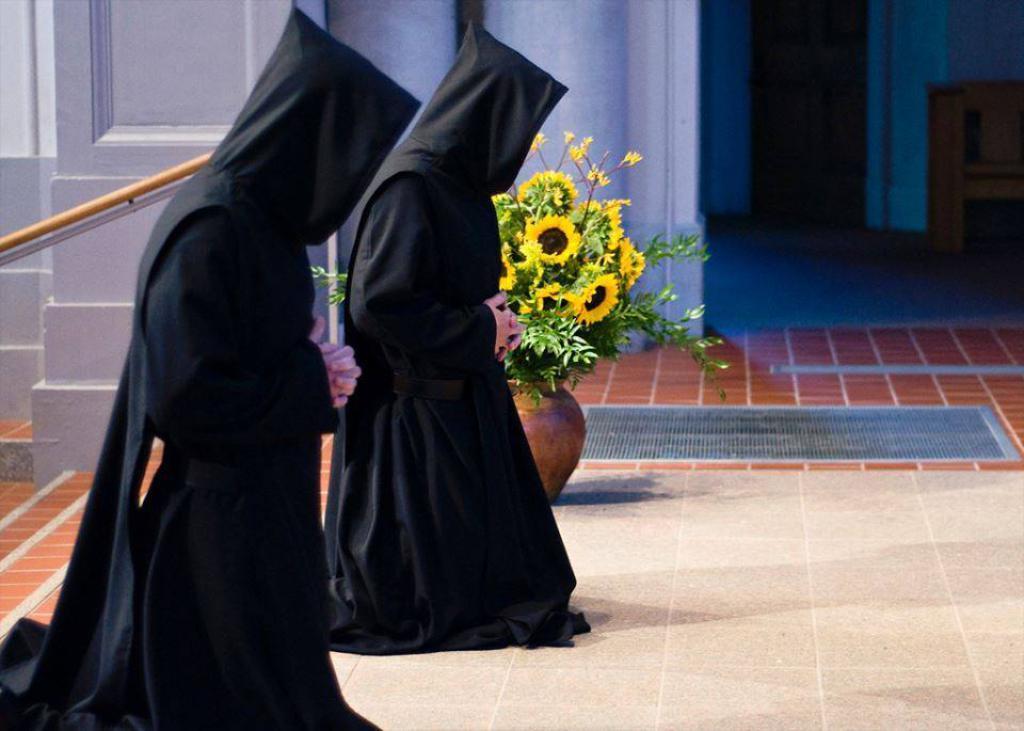Please provide a concise description of this image. This image is taken orders. At the bottom of the image there is a floor. In the background there is a wall and there is a pillar. There is of flower vase with flowers. On the left side of the image two women are sitting on the knees and praying god. 